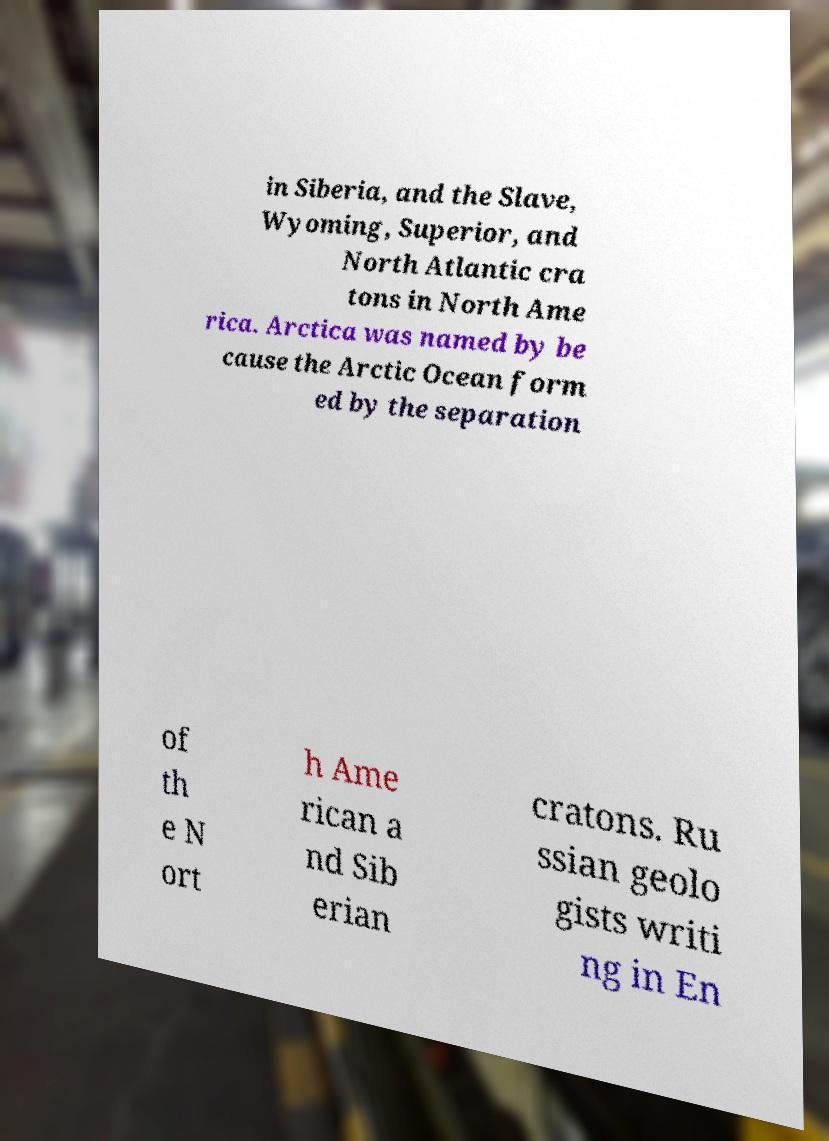Please identify and transcribe the text found in this image. in Siberia, and the Slave, Wyoming, Superior, and North Atlantic cra tons in North Ame rica. Arctica was named by be cause the Arctic Ocean form ed by the separation of th e N ort h Ame rican a nd Sib erian cratons. Ru ssian geolo gists writi ng in En 